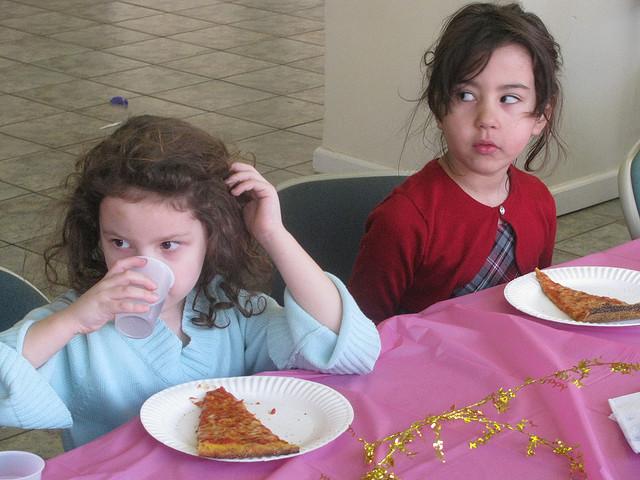Are both girls drinking?
Give a very brief answer. No. Do the girls need their hair done?
Keep it brief. Yes. What is the girl in the red shirt looking at?
Give a very brief answer. Person. How many people are wearing glasses?
Concise answer only. 0. Are the children playing?
Give a very brief answer. No. 